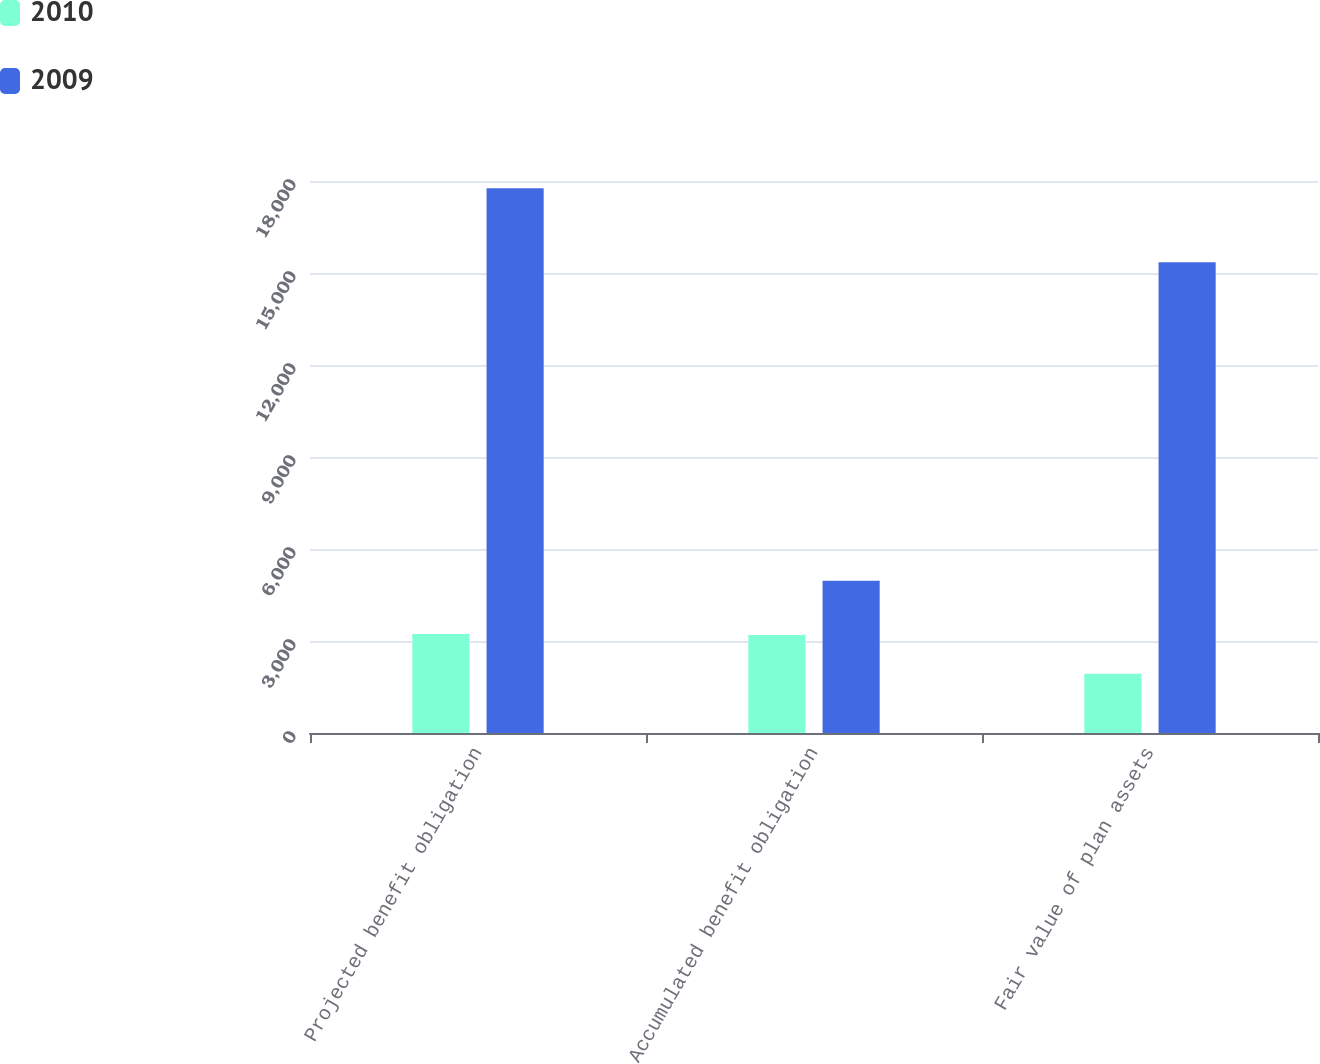<chart> <loc_0><loc_0><loc_500><loc_500><stacked_bar_chart><ecel><fcel>Projected benefit obligation<fcel>Accumulated benefit obligation<fcel>Fair value of plan assets<nl><fcel>2010<fcel>3227<fcel>3195<fcel>1934<nl><fcel>2009<fcel>17763<fcel>4963<fcel>15351<nl></chart> 